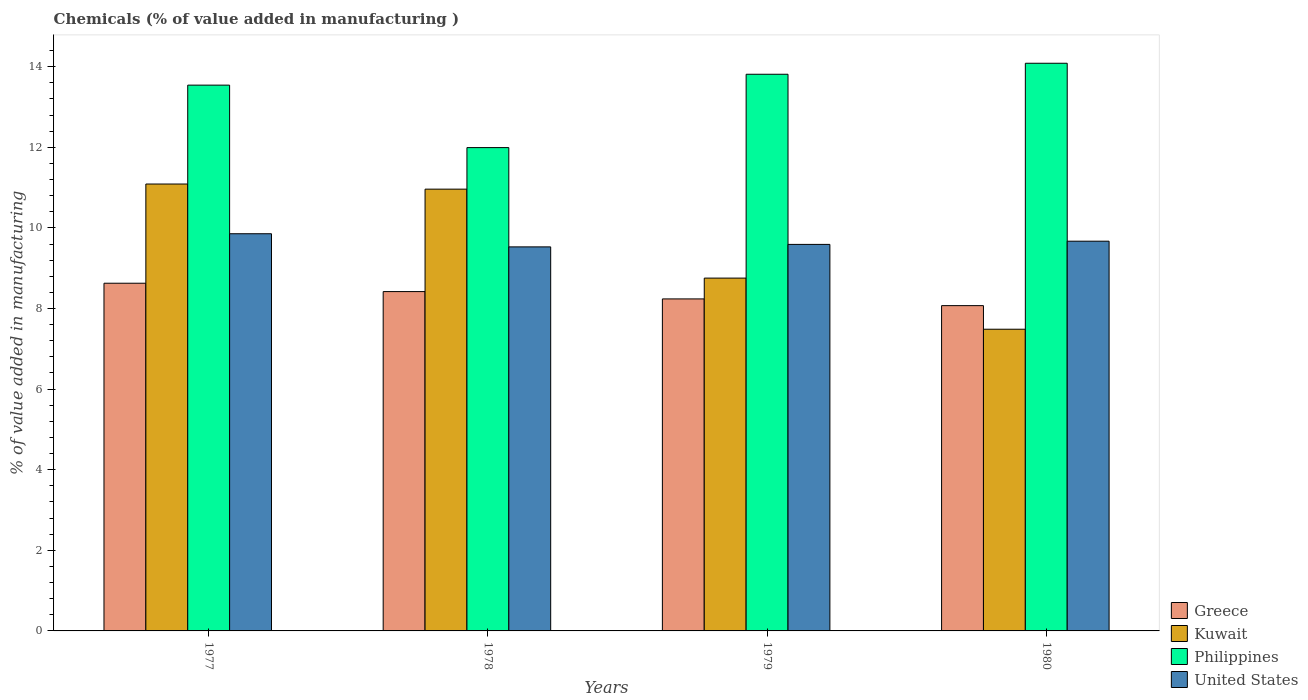Are the number of bars on each tick of the X-axis equal?
Ensure brevity in your answer.  Yes. How many bars are there on the 3rd tick from the left?
Offer a terse response. 4. How many bars are there on the 2nd tick from the right?
Offer a very short reply. 4. What is the label of the 2nd group of bars from the left?
Offer a terse response. 1978. In how many cases, is the number of bars for a given year not equal to the number of legend labels?
Keep it short and to the point. 0. What is the value added in manufacturing chemicals in United States in 1978?
Ensure brevity in your answer.  9.53. Across all years, what is the maximum value added in manufacturing chemicals in Philippines?
Your response must be concise. 14.09. Across all years, what is the minimum value added in manufacturing chemicals in Greece?
Give a very brief answer. 8.07. In which year was the value added in manufacturing chemicals in Greece maximum?
Make the answer very short. 1977. In which year was the value added in manufacturing chemicals in United States minimum?
Offer a very short reply. 1978. What is the total value added in manufacturing chemicals in Greece in the graph?
Provide a short and direct response. 33.36. What is the difference between the value added in manufacturing chemicals in Philippines in 1978 and that in 1979?
Make the answer very short. -1.82. What is the difference between the value added in manufacturing chemicals in Greece in 1977 and the value added in manufacturing chemicals in Kuwait in 1978?
Make the answer very short. -2.33. What is the average value added in manufacturing chemicals in Kuwait per year?
Provide a succinct answer. 9.57. In the year 1980, what is the difference between the value added in manufacturing chemicals in Greece and value added in manufacturing chemicals in United States?
Your answer should be very brief. -1.6. What is the ratio of the value added in manufacturing chemicals in Greece in 1978 to that in 1979?
Your answer should be very brief. 1.02. Is the value added in manufacturing chemicals in Greece in 1977 less than that in 1979?
Offer a terse response. No. What is the difference between the highest and the second highest value added in manufacturing chemicals in Kuwait?
Provide a short and direct response. 0.13. What is the difference between the highest and the lowest value added in manufacturing chemicals in Greece?
Give a very brief answer. 0.56. In how many years, is the value added in manufacturing chemicals in Philippines greater than the average value added in manufacturing chemicals in Philippines taken over all years?
Give a very brief answer. 3. Is the sum of the value added in manufacturing chemicals in Kuwait in 1977 and 1980 greater than the maximum value added in manufacturing chemicals in United States across all years?
Give a very brief answer. Yes. What does the 4th bar from the right in 1979 represents?
Your answer should be compact. Greece. How many bars are there?
Give a very brief answer. 16. Are all the bars in the graph horizontal?
Your response must be concise. No. What is the difference between two consecutive major ticks on the Y-axis?
Offer a very short reply. 2. Are the values on the major ticks of Y-axis written in scientific E-notation?
Offer a very short reply. No. Does the graph contain grids?
Offer a very short reply. No. How many legend labels are there?
Give a very brief answer. 4. What is the title of the graph?
Give a very brief answer. Chemicals (% of value added in manufacturing ). Does "Germany" appear as one of the legend labels in the graph?
Keep it short and to the point. No. What is the label or title of the Y-axis?
Make the answer very short. % of value added in manufacturing. What is the % of value added in manufacturing of Greece in 1977?
Your response must be concise. 8.63. What is the % of value added in manufacturing in Kuwait in 1977?
Offer a terse response. 11.09. What is the % of value added in manufacturing in Philippines in 1977?
Ensure brevity in your answer.  13.54. What is the % of value added in manufacturing in United States in 1977?
Ensure brevity in your answer.  9.85. What is the % of value added in manufacturing in Greece in 1978?
Your answer should be very brief. 8.42. What is the % of value added in manufacturing in Kuwait in 1978?
Your response must be concise. 10.96. What is the % of value added in manufacturing in Philippines in 1978?
Give a very brief answer. 11.99. What is the % of value added in manufacturing in United States in 1978?
Your answer should be compact. 9.53. What is the % of value added in manufacturing in Greece in 1979?
Provide a succinct answer. 8.24. What is the % of value added in manufacturing in Kuwait in 1979?
Your answer should be compact. 8.75. What is the % of value added in manufacturing of Philippines in 1979?
Offer a terse response. 13.81. What is the % of value added in manufacturing of United States in 1979?
Make the answer very short. 9.59. What is the % of value added in manufacturing in Greece in 1980?
Your response must be concise. 8.07. What is the % of value added in manufacturing of Kuwait in 1980?
Offer a terse response. 7.49. What is the % of value added in manufacturing in Philippines in 1980?
Your answer should be very brief. 14.09. What is the % of value added in manufacturing in United States in 1980?
Offer a terse response. 9.67. Across all years, what is the maximum % of value added in manufacturing in Greece?
Your answer should be compact. 8.63. Across all years, what is the maximum % of value added in manufacturing in Kuwait?
Your answer should be very brief. 11.09. Across all years, what is the maximum % of value added in manufacturing in Philippines?
Keep it short and to the point. 14.09. Across all years, what is the maximum % of value added in manufacturing in United States?
Your response must be concise. 9.85. Across all years, what is the minimum % of value added in manufacturing of Greece?
Provide a short and direct response. 8.07. Across all years, what is the minimum % of value added in manufacturing of Kuwait?
Offer a terse response. 7.49. Across all years, what is the minimum % of value added in manufacturing of Philippines?
Keep it short and to the point. 11.99. Across all years, what is the minimum % of value added in manufacturing of United States?
Your answer should be compact. 9.53. What is the total % of value added in manufacturing of Greece in the graph?
Ensure brevity in your answer.  33.36. What is the total % of value added in manufacturing in Kuwait in the graph?
Provide a short and direct response. 38.29. What is the total % of value added in manufacturing of Philippines in the graph?
Your response must be concise. 53.43. What is the total % of value added in manufacturing in United States in the graph?
Make the answer very short. 38.64. What is the difference between the % of value added in manufacturing of Greece in 1977 and that in 1978?
Make the answer very short. 0.21. What is the difference between the % of value added in manufacturing of Kuwait in 1977 and that in 1978?
Keep it short and to the point. 0.13. What is the difference between the % of value added in manufacturing of Philippines in 1977 and that in 1978?
Make the answer very short. 1.55. What is the difference between the % of value added in manufacturing in United States in 1977 and that in 1978?
Offer a terse response. 0.33. What is the difference between the % of value added in manufacturing in Greece in 1977 and that in 1979?
Provide a succinct answer. 0.39. What is the difference between the % of value added in manufacturing of Kuwait in 1977 and that in 1979?
Provide a short and direct response. 2.33. What is the difference between the % of value added in manufacturing of Philippines in 1977 and that in 1979?
Give a very brief answer. -0.27. What is the difference between the % of value added in manufacturing in United States in 1977 and that in 1979?
Keep it short and to the point. 0.26. What is the difference between the % of value added in manufacturing of Greece in 1977 and that in 1980?
Offer a very short reply. 0.56. What is the difference between the % of value added in manufacturing of Kuwait in 1977 and that in 1980?
Offer a very short reply. 3.6. What is the difference between the % of value added in manufacturing of Philippines in 1977 and that in 1980?
Your response must be concise. -0.54. What is the difference between the % of value added in manufacturing of United States in 1977 and that in 1980?
Provide a succinct answer. 0.18. What is the difference between the % of value added in manufacturing of Greece in 1978 and that in 1979?
Give a very brief answer. 0.18. What is the difference between the % of value added in manufacturing of Kuwait in 1978 and that in 1979?
Give a very brief answer. 2.21. What is the difference between the % of value added in manufacturing in Philippines in 1978 and that in 1979?
Make the answer very short. -1.82. What is the difference between the % of value added in manufacturing of United States in 1978 and that in 1979?
Provide a short and direct response. -0.06. What is the difference between the % of value added in manufacturing in Greece in 1978 and that in 1980?
Ensure brevity in your answer.  0.35. What is the difference between the % of value added in manufacturing of Kuwait in 1978 and that in 1980?
Your answer should be compact. 3.48. What is the difference between the % of value added in manufacturing in Philippines in 1978 and that in 1980?
Ensure brevity in your answer.  -2.09. What is the difference between the % of value added in manufacturing of United States in 1978 and that in 1980?
Ensure brevity in your answer.  -0.14. What is the difference between the % of value added in manufacturing in Greece in 1979 and that in 1980?
Keep it short and to the point. 0.17. What is the difference between the % of value added in manufacturing of Kuwait in 1979 and that in 1980?
Offer a very short reply. 1.27. What is the difference between the % of value added in manufacturing of Philippines in 1979 and that in 1980?
Offer a very short reply. -0.27. What is the difference between the % of value added in manufacturing in United States in 1979 and that in 1980?
Offer a terse response. -0.08. What is the difference between the % of value added in manufacturing in Greece in 1977 and the % of value added in manufacturing in Kuwait in 1978?
Keep it short and to the point. -2.33. What is the difference between the % of value added in manufacturing in Greece in 1977 and the % of value added in manufacturing in Philippines in 1978?
Give a very brief answer. -3.37. What is the difference between the % of value added in manufacturing in Greece in 1977 and the % of value added in manufacturing in United States in 1978?
Keep it short and to the point. -0.9. What is the difference between the % of value added in manufacturing in Kuwait in 1977 and the % of value added in manufacturing in Philippines in 1978?
Offer a very short reply. -0.9. What is the difference between the % of value added in manufacturing of Kuwait in 1977 and the % of value added in manufacturing of United States in 1978?
Your answer should be compact. 1.56. What is the difference between the % of value added in manufacturing in Philippines in 1977 and the % of value added in manufacturing in United States in 1978?
Ensure brevity in your answer.  4.01. What is the difference between the % of value added in manufacturing of Greece in 1977 and the % of value added in manufacturing of Kuwait in 1979?
Keep it short and to the point. -0.13. What is the difference between the % of value added in manufacturing in Greece in 1977 and the % of value added in manufacturing in Philippines in 1979?
Your answer should be very brief. -5.18. What is the difference between the % of value added in manufacturing of Greece in 1977 and the % of value added in manufacturing of United States in 1979?
Your answer should be very brief. -0.96. What is the difference between the % of value added in manufacturing in Kuwait in 1977 and the % of value added in manufacturing in Philippines in 1979?
Your answer should be very brief. -2.72. What is the difference between the % of value added in manufacturing of Kuwait in 1977 and the % of value added in manufacturing of United States in 1979?
Provide a short and direct response. 1.5. What is the difference between the % of value added in manufacturing of Philippines in 1977 and the % of value added in manufacturing of United States in 1979?
Offer a terse response. 3.95. What is the difference between the % of value added in manufacturing of Greece in 1977 and the % of value added in manufacturing of Kuwait in 1980?
Provide a short and direct response. 1.14. What is the difference between the % of value added in manufacturing of Greece in 1977 and the % of value added in manufacturing of Philippines in 1980?
Offer a terse response. -5.46. What is the difference between the % of value added in manufacturing in Greece in 1977 and the % of value added in manufacturing in United States in 1980?
Your response must be concise. -1.04. What is the difference between the % of value added in manufacturing in Kuwait in 1977 and the % of value added in manufacturing in Philippines in 1980?
Your answer should be compact. -3. What is the difference between the % of value added in manufacturing in Kuwait in 1977 and the % of value added in manufacturing in United States in 1980?
Give a very brief answer. 1.42. What is the difference between the % of value added in manufacturing of Philippines in 1977 and the % of value added in manufacturing of United States in 1980?
Your response must be concise. 3.87. What is the difference between the % of value added in manufacturing of Greece in 1978 and the % of value added in manufacturing of Kuwait in 1979?
Give a very brief answer. -0.33. What is the difference between the % of value added in manufacturing in Greece in 1978 and the % of value added in manufacturing in Philippines in 1979?
Keep it short and to the point. -5.39. What is the difference between the % of value added in manufacturing in Greece in 1978 and the % of value added in manufacturing in United States in 1979?
Provide a succinct answer. -1.17. What is the difference between the % of value added in manufacturing in Kuwait in 1978 and the % of value added in manufacturing in Philippines in 1979?
Your response must be concise. -2.85. What is the difference between the % of value added in manufacturing of Kuwait in 1978 and the % of value added in manufacturing of United States in 1979?
Provide a succinct answer. 1.37. What is the difference between the % of value added in manufacturing of Philippines in 1978 and the % of value added in manufacturing of United States in 1979?
Provide a short and direct response. 2.4. What is the difference between the % of value added in manufacturing in Greece in 1978 and the % of value added in manufacturing in Kuwait in 1980?
Ensure brevity in your answer.  0.93. What is the difference between the % of value added in manufacturing of Greece in 1978 and the % of value added in manufacturing of Philippines in 1980?
Give a very brief answer. -5.67. What is the difference between the % of value added in manufacturing in Greece in 1978 and the % of value added in manufacturing in United States in 1980?
Make the answer very short. -1.25. What is the difference between the % of value added in manufacturing in Kuwait in 1978 and the % of value added in manufacturing in Philippines in 1980?
Give a very brief answer. -3.12. What is the difference between the % of value added in manufacturing of Kuwait in 1978 and the % of value added in manufacturing of United States in 1980?
Offer a terse response. 1.29. What is the difference between the % of value added in manufacturing in Philippines in 1978 and the % of value added in manufacturing in United States in 1980?
Your response must be concise. 2.32. What is the difference between the % of value added in manufacturing of Greece in 1979 and the % of value added in manufacturing of Kuwait in 1980?
Provide a succinct answer. 0.75. What is the difference between the % of value added in manufacturing in Greece in 1979 and the % of value added in manufacturing in Philippines in 1980?
Your answer should be compact. -5.85. What is the difference between the % of value added in manufacturing of Greece in 1979 and the % of value added in manufacturing of United States in 1980?
Your response must be concise. -1.43. What is the difference between the % of value added in manufacturing in Kuwait in 1979 and the % of value added in manufacturing in Philippines in 1980?
Provide a succinct answer. -5.33. What is the difference between the % of value added in manufacturing of Kuwait in 1979 and the % of value added in manufacturing of United States in 1980?
Ensure brevity in your answer.  -0.92. What is the difference between the % of value added in manufacturing of Philippines in 1979 and the % of value added in manufacturing of United States in 1980?
Offer a very short reply. 4.14. What is the average % of value added in manufacturing of Greece per year?
Give a very brief answer. 8.34. What is the average % of value added in manufacturing of Kuwait per year?
Ensure brevity in your answer.  9.57. What is the average % of value added in manufacturing of Philippines per year?
Your answer should be compact. 13.36. What is the average % of value added in manufacturing in United States per year?
Make the answer very short. 9.66. In the year 1977, what is the difference between the % of value added in manufacturing in Greece and % of value added in manufacturing in Kuwait?
Provide a short and direct response. -2.46. In the year 1977, what is the difference between the % of value added in manufacturing in Greece and % of value added in manufacturing in Philippines?
Make the answer very short. -4.92. In the year 1977, what is the difference between the % of value added in manufacturing in Greece and % of value added in manufacturing in United States?
Provide a short and direct response. -1.23. In the year 1977, what is the difference between the % of value added in manufacturing of Kuwait and % of value added in manufacturing of Philippines?
Provide a short and direct response. -2.45. In the year 1977, what is the difference between the % of value added in manufacturing in Kuwait and % of value added in manufacturing in United States?
Provide a short and direct response. 1.23. In the year 1977, what is the difference between the % of value added in manufacturing in Philippines and % of value added in manufacturing in United States?
Offer a terse response. 3.69. In the year 1978, what is the difference between the % of value added in manufacturing in Greece and % of value added in manufacturing in Kuwait?
Ensure brevity in your answer.  -2.54. In the year 1978, what is the difference between the % of value added in manufacturing of Greece and % of value added in manufacturing of Philippines?
Give a very brief answer. -3.57. In the year 1978, what is the difference between the % of value added in manufacturing of Greece and % of value added in manufacturing of United States?
Give a very brief answer. -1.11. In the year 1978, what is the difference between the % of value added in manufacturing in Kuwait and % of value added in manufacturing in Philippines?
Make the answer very short. -1.03. In the year 1978, what is the difference between the % of value added in manufacturing in Kuwait and % of value added in manufacturing in United States?
Provide a short and direct response. 1.43. In the year 1978, what is the difference between the % of value added in manufacturing in Philippines and % of value added in manufacturing in United States?
Your answer should be very brief. 2.46. In the year 1979, what is the difference between the % of value added in manufacturing in Greece and % of value added in manufacturing in Kuwait?
Your answer should be compact. -0.52. In the year 1979, what is the difference between the % of value added in manufacturing in Greece and % of value added in manufacturing in Philippines?
Offer a terse response. -5.57. In the year 1979, what is the difference between the % of value added in manufacturing in Greece and % of value added in manufacturing in United States?
Provide a succinct answer. -1.35. In the year 1979, what is the difference between the % of value added in manufacturing in Kuwait and % of value added in manufacturing in Philippines?
Offer a terse response. -5.06. In the year 1979, what is the difference between the % of value added in manufacturing in Kuwait and % of value added in manufacturing in United States?
Offer a terse response. -0.84. In the year 1979, what is the difference between the % of value added in manufacturing in Philippines and % of value added in manufacturing in United States?
Ensure brevity in your answer.  4.22. In the year 1980, what is the difference between the % of value added in manufacturing in Greece and % of value added in manufacturing in Kuwait?
Ensure brevity in your answer.  0.59. In the year 1980, what is the difference between the % of value added in manufacturing in Greece and % of value added in manufacturing in Philippines?
Your response must be concise. -6.01. In the year 1980, what is the difference between the % of value added in manufacturing in Greece and % of value added in manufacturing in United States?
Ensure brevity in your answer.  -1.6. In the year 1980, what is the difference between the % of value added in manufacturing of Kuwait and % of value added in manufacturing of Philippines?
Provide a short and direct response. -6.6. In the year 1980, what is the difference between the % of value added in manufacturing in Kuwait and % of value added in manufacturing in United States?
Give a very brief answer. -2.18. In the year 1980, what is the difference between the % of value added in manufacturing of Philippines and % of value added in manufacturing of United States?
Your answer should be compact. 4.41. What is the ratio of the % of value added in manufacturing in Greece in 1977 to that in 1978?
Offer a very short reply. 1.02. What is the ratio of the % of value added in manufacturing in Kuwait in 1977 to that in 1978?
Your answer should be compact. 1.01. What is the ratio of the % of value added in manufacturing in Philippines in 1977 to that in 1978?
Ensure brevity in your answer.  1.13. What is the ratio of the % of value added in manufacturing in United States in 1977 to that in 1978?
Your answer should be very brief. 1.03. What is the ratio of the % of value added in manufacturing of Greece in 1977 to that in 1979?
Give a very brief answer. 1.05. What is the ratio of the % of value added in manufacturing in Kuwait in 1977 to that in 1979?
Your response must be concise. 1.27. What is the ratio of the % of value added in manufacturing of Philippines in 1977 to that in 1979?
Provide a succinct answer. 0.98. What is the ratio of the % of value added in manufacturing in United States in 1977 to that in 1979?
Offer a terse response. 1.03. What is the ratio of the % of value added in manufacturing of Greece in 1977 to that in 1980?
Give a very brief answer. 1.07. What is the ratio of the % of value added in manufacturing of Kuwait in 1977 to that in 1980?
Provide a succinct answer. 1.48. What is the ratio of the % of value added in manufacturing in Philippines in 1977 to that in 1980?
Give a very brief answer. 0.96. What is the ratio of the % of value added in manufacturing in United States in 1977 to that in 1980?
Your answer should be compact. 1.02. What is the ratio of the % of value added in manufacturing in Greece in 1978 to that in 1979?
Your answer should be very brief. 1.02. What is the ratio of the % of value added in manufacturing in Kuwait in 1978 to that in 1979?
Ensure brevity in your answer.  1.25. What is the ratio of the % of value added in manufacturing of Philippines in 1978 to that in 1979?
Offer a very short reply. 0.87. What is the ratio of the % of value added in manufacturing of United States in 1978 to that in 1979?
Make the answer very short. 0.99. What is the ratio of the % of value added in manufacturing in Greece in 1978 to that in 1980?
Provide a succinct answer. 1.04. What is the ratio of the % of value added in manufacturing of Kuwait in 1978 to that in 1980?
Ensure brevity in your answer.  1.46. What is the ratio of the % of value added in manufacturing of Philippines in 1978 to that in 1980?
Offer a terse response. 0.85. What is the ratio of the % of value added in manufacturing in United States in 1978 to that in 1980?
Make the answer very short. 0.99. What is the ratio of the % of value added in manufacturing in Greece in 1979 to that in 1980?
Your response must be concise. 1.02. What is the ratio of the % of value added in manufacturing in Kuwait in 1979 to that in 1980?
Keep it short and to the point. 1.17. What is the ratio of the % of value added in manufacturing of Philippines in 1979 to that in 1980?
Provide a succinct answer. 0.98. What is the difference between the highest and the second highest % of value added in manufacturing of Greece?
Make the answer very short. 0.21. What is the difference between the highest and the second highest % of value added in manufacturing in Kuwait?
Offer a terse response. 0.13. What is the difference between the highest and the second highest % of value added in manufacturing in Philippines?
Provide a succinct answer. 0.27. What is the difference between the highest and the second highest % of value added in manufacturing of United States?
Your answer should be very brief. 0.18. What is the difference between the highest and the lowest % of value added in manufacturing in Greece?
Your answer should be very brief. 0.56. What is the difference between the highest and the lowest % of value added in manufacturing of Kuwait?
Offer a very short reply. 3.6. What is the difference between the highest and the lowest % of value added in manufacturing of Philippines?
Ensure brevity in your answer.  2.09. What is the difference between the highest and the lowest % of value added in manufacturing in United States?
Your answer should be very brief. 0.33. 